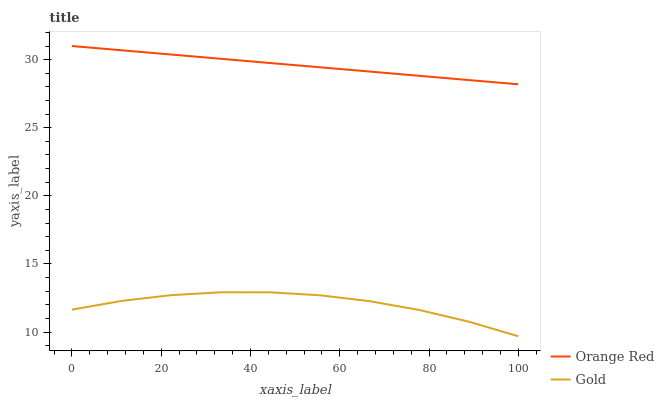Does Gold have the maximum area under the curve?
Answer yes or no. No. Is Gold the smoothest?
Answer yes or no. No. Does Gold have the highest value?
Answer yes or no. No. Is Gold less than Orange Red?
Answer yes or no. Yes. Is Orange Red greater than Gold?
Answer yes or no. Yes. Does Gold intersect Orange Red?
Answer yes or no. No. 